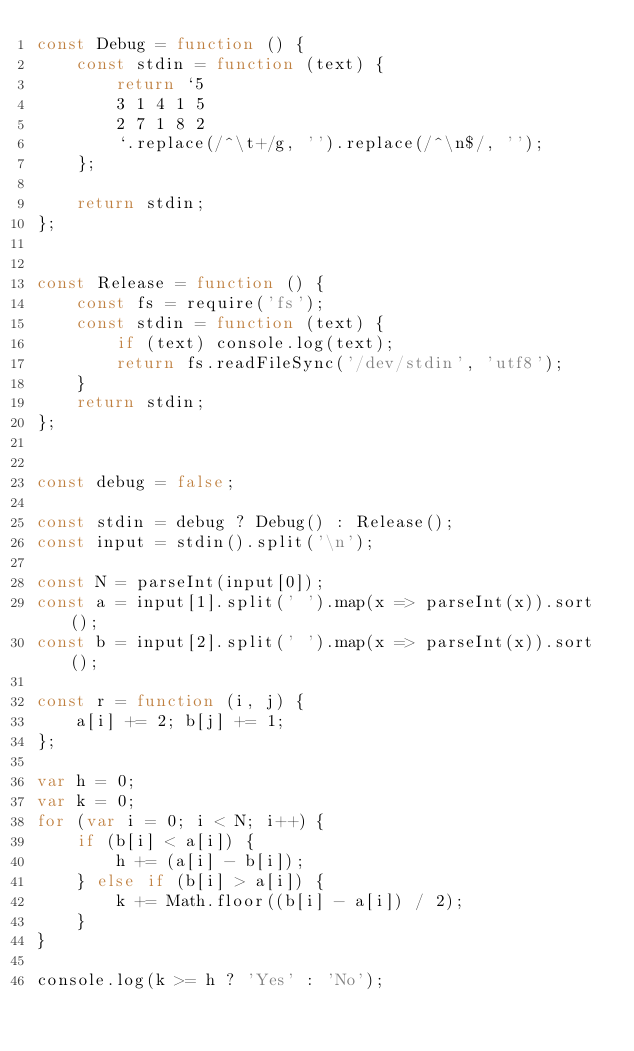Convert code to text. <code><loc_0><loc_0><loc_500><loc_500><_JavaScript_>const Debug = function () {
    const stdin = function (text) {
        return `5
        3 1 4 1 5
        2 7 1 8 2
        `.replace(/^\t+/g, '').replace(/^\n$/, '');
    };

    return stdin;
};


const Release = function () {
    const fs = require('fs');
    const stdin = function (text) {
        if (text) console.log(text);
        return fs.readFileSync('/dev/stdin', 'utf8');
    }
    return stdin;
};


const debug = false;

const stdin = debug ? Debug() : Release();
const input = stdin().split('\n');

const N = parseInt(input[0]);
const a = input[1].split(' ').map(x => parseInt(x)).sort();
const b = input[2].split(' ').map(x => parseInt(x)).sort();

const r = function (i, j) {
    a[i] += 2; b[j] += 1;
};

var h = 0;
var k = 0;
for (var i = 0; i < N; i++) {
    if (b[i] < a[i]) {
        h += (a[i] - b[i]);
    } else if (b[i] > a[i]) {
        k += Math.floor((b[i] - a[i]) / 2);
    }
}

console.log(k >= h ? 'Yes' : 'No');</code> 